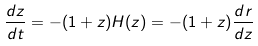<formula> <loc_0><loc_0><loc_500><loc_500>\frac { d z } { d t } = - ( 1 + z ) H ( z ) = - ( 1 + z ) \frac { d r } { d z }</formula> 